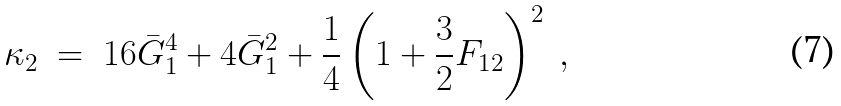<formula> <loc_0><loc_0><loc_500><loc_500>\kappa _ { 2 } \ = \ 1 6 \bar { G } _ { 1 } ^ { 4 } + 4 \bar { G } _ { 1 } ^ { 2 } + \frac { 1 } { 4 } \left ( 1 + \frac { 3 } { 2 } F _ { 1 2 } \right ) ^ { 2 } \ ,</formula> 